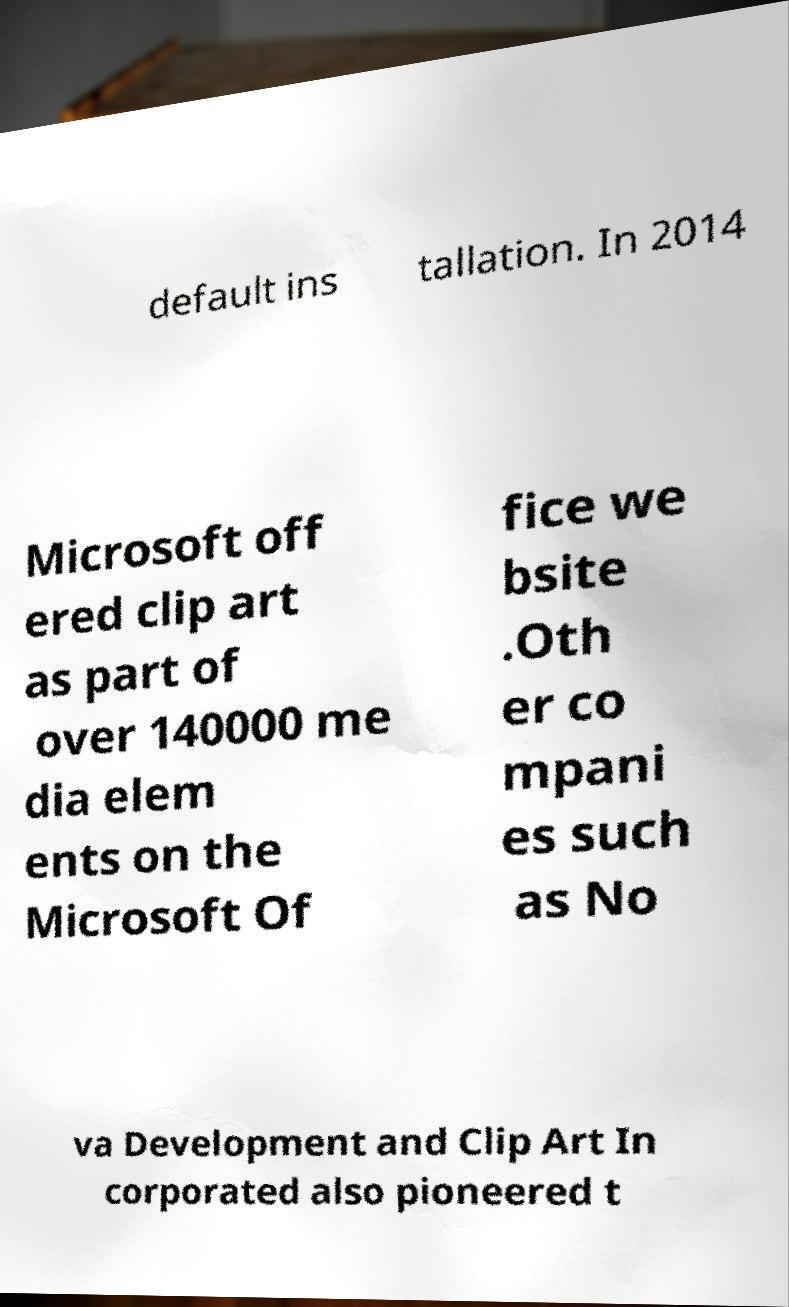There's text embedded in this image that I need extracted. Can you transcribe it verbatim? default ins tallation. In 2014 Microsoft off ered clip art as part of over 140000 me dia elem ents on the Microsoft Of fice we bsite .Oth er co mpani es such as No va Development and Clip Art In corporated also pioneered t 